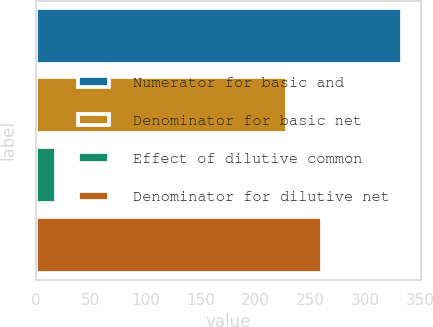<chart> <loc_0><loc_0><loc_500><loc_500><bar_chart><fcel>Numerator for basic and<fcel>Denominator for basic net<fcel>Effect of dilutive common<fcel>Denominator for dilutive net<nl><fcel>333.6<fcel>229<fcel>18.5<fcel>260.51<nl></chart> 